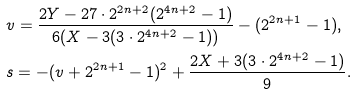Convert formula to latex. <formula><loc_0><loc_0><loc_500><loc_500>& v = \frac { 2 Y - 2 7 \cdot 2 ^ { 2 n + 2 } ( 2 ^ { 4 n + 2 } - 1 ) } { 6 ( X - 3 ( 3 \cdot 2 ^ { 4 n + 2 } - 1 ) ) } - ( 2 ^ { 2 n + 1 } - 1 ) , \\ & s = - ( v + 2 ^ { 2 n + 1 } - 1 ) ^ { 2 } + \frac { 2 X + 3 ( 3 \cdot 2 ^ { 4 n + 2 } - 1 ) } { 9 } .</formula> 